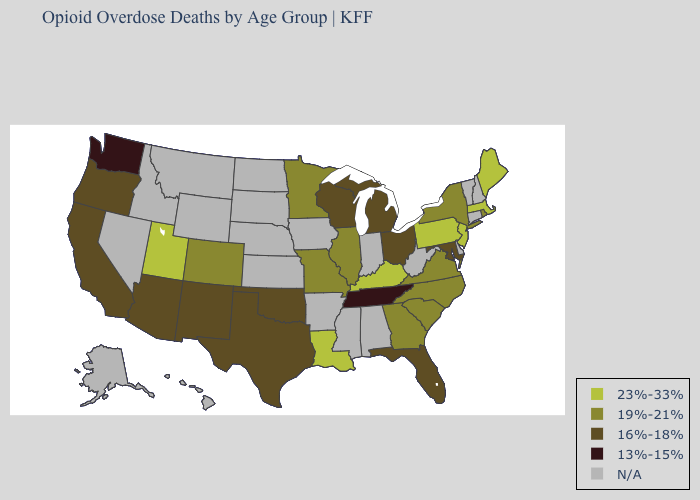Name the states that have a value in the range 23%-33%?
Answer briefly. Kentucky, Louisiana, Maine, Massachusetts, New Jersey, Pennsylvania, Utah. What is the value of Rhode Island?
Keep it brief. 19%-21%. Which states have the highest value in the USA?
Give a very brief answer. Kentucky, Louisiana, Maine, Massachusetts, New Jersey, Pennsylvania, Utah. What is the highest value in states that border Oklahoma?
Short answer required. 19%-21%. Does New York have the highest value in the Northeast?
Be succinct. No. Which states have the highest value in the USA?
Short answer required. Kentucky, Louisiana, Maine, Massachusetts, New Jersey, Pennsylvania, Utah. Name the states that have a value in the range 19%-21%?
Quick response, please. Colorado, Georgia, Illinois, Minnesota, Missouri, New York, North Carolina, Rhode Island, South Carolina, Virginia. Among the states that border Ohio , does Michigan have the highest value?
Concise answer only. No. Among the states that border Vermont , which have the lowest value?
Keep it brief. New York. Name the states that have a value in the range 23%-33%?
Answer briefly. Kentucky, Louisiana, Maine, Massachusetts, New Jersey, Pennsylvania, Utah. What is the value of Oklahoma?
Keep it brief. 16%-18%. Does Rhode Island have the highest value in the Northeast?
Answer briefly. No. Does Washington have the lowest value in the USA?
Keep it brief. Yes. Is the legend a continuous bar?
Write a very short answer. No. Does New Jersey have the highest value in the USA?
Write a very short answer. Yes. 